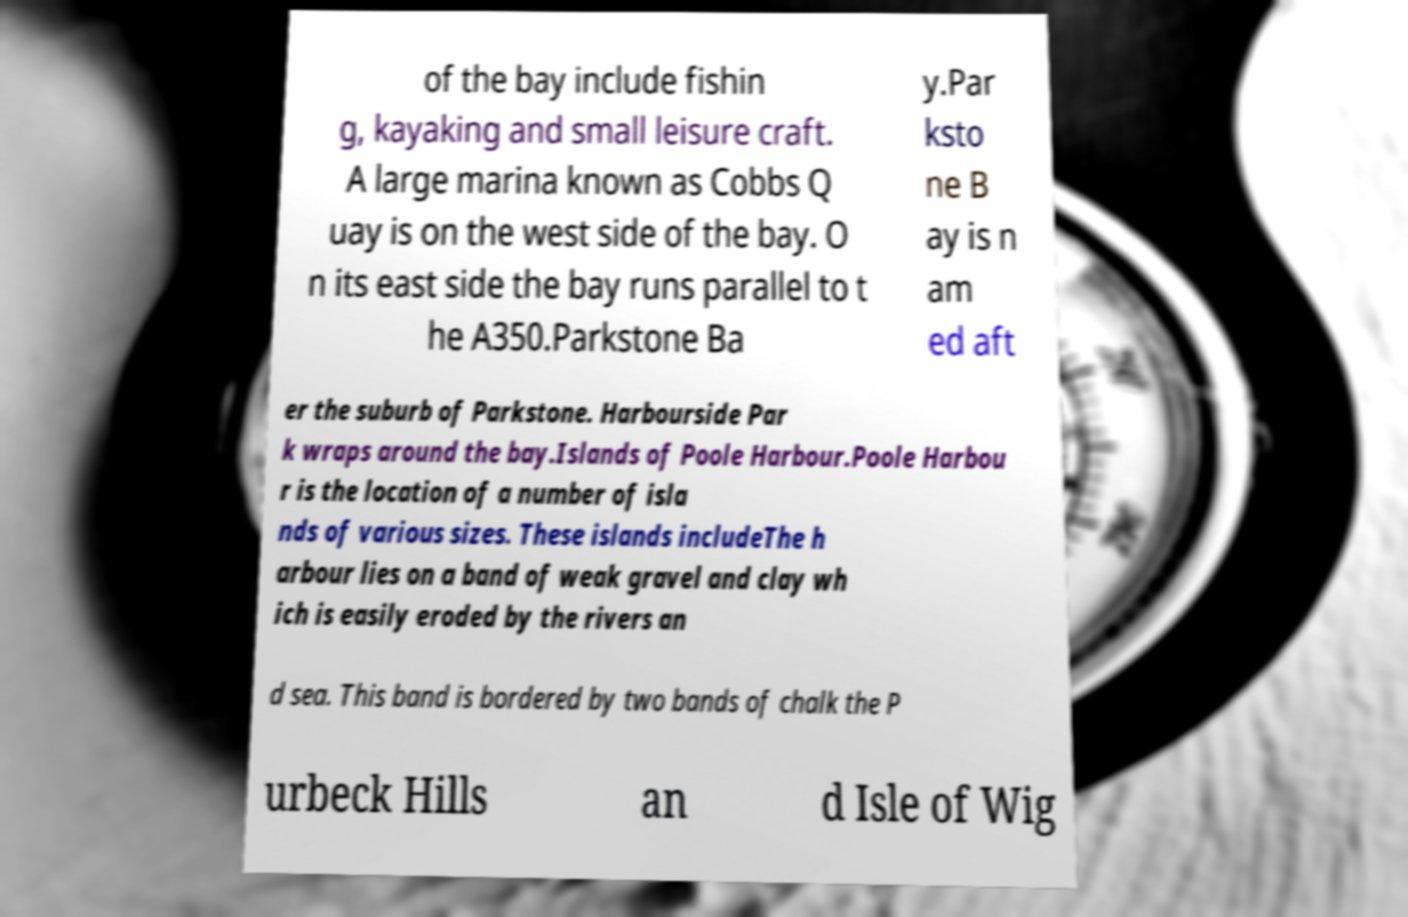There's text embedded in this image that I need extracted. Can you transcribe it verbatim? of the bay include fishin g, kayaking and small leisure craft. A large marina known as Cobbs Q uay is on the west side of the bay. O n its east side the bay runs parallel to t he A350.Parkstone Ba y.Par ksto ne B ay is n am ed aft er the suburb of Parkstone. Harbourside Par k wraps around the bay.Islands of Poole Harbour.Poole Harbou r is the location of a number of isla nds of various sizes. These islands includeThe h arbour lies on a band of weak gravel and clay wh ich is easily eroded by the rivers an d sea. This band is bordered by two bands of chalk the P urbeck Hills an d Isle of Wig 